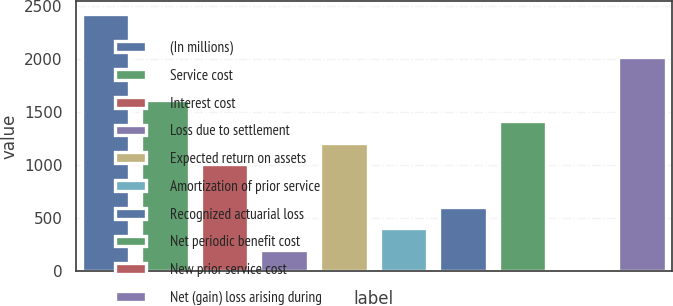Convert chart. <chart><loc_0><loc_0><loc_500><loc_500><bar_chart><fcel>(In millions)<fcel>Service cost<fcel>Interest cost<fcel>Loss due to settlement<fcel>Expected return on assets<fcel>Amortization of prior service<fcel>Recognized actuarial loss<fcel>Net periodic benefit cost<fcel>New prior service cost<fcel>Net (gain) loss arising during<nl><fcel>2422.64<fcel>1615.36<fcel>1009.9<fcel>202.62<fcel>1211.72<fcel>404.44<fcel>606.26<fcel>1413.54<fcel>0.8<fcel>2019<nl></chart> 